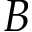<formula> <loc_0><loc_0><loc_500><loc_500>B</formula> 